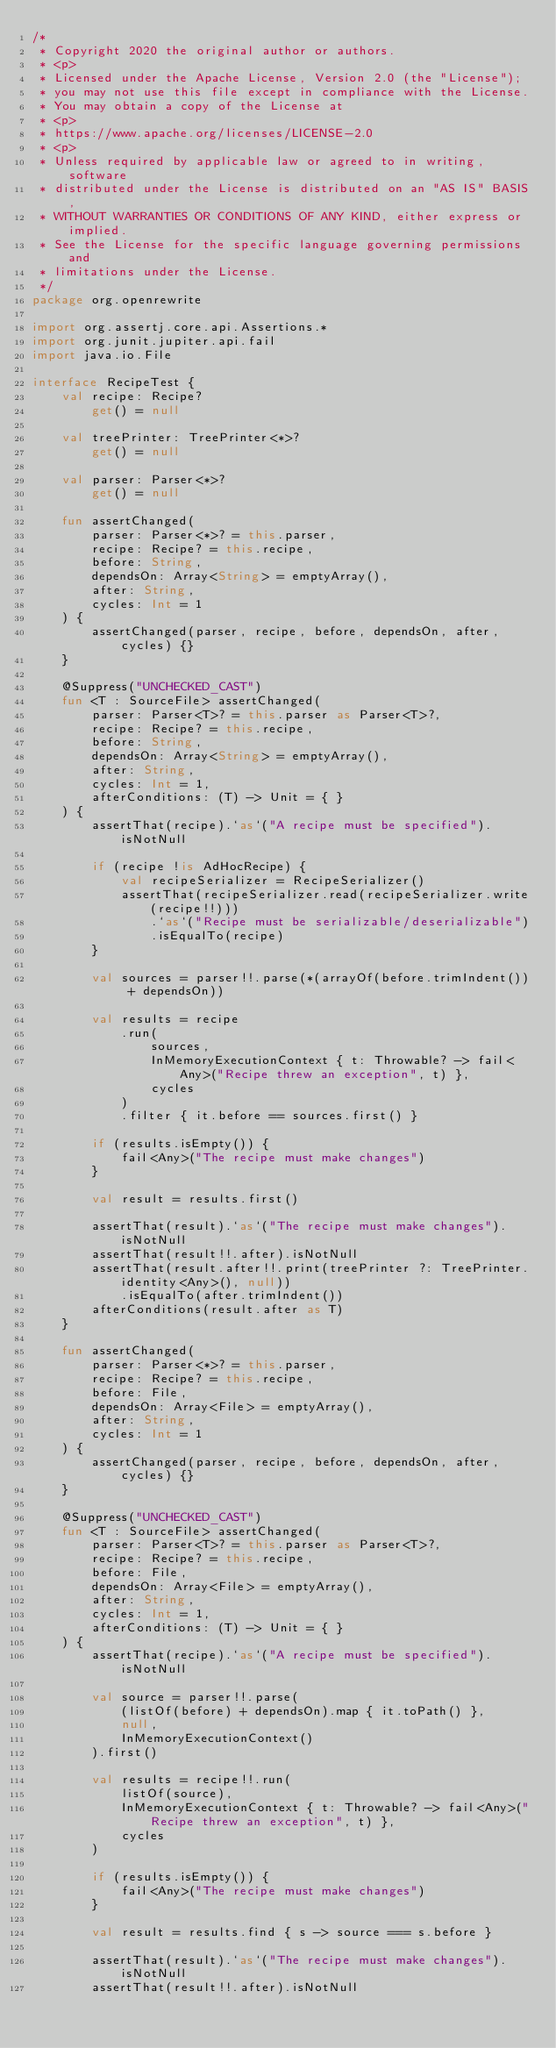<code> <loc_0><loc_0><loc_500><loc_500><_Kotlin_>/*
 * Copyright 2020 the original author or authors.
 * <p>
 * Licensed under the Apache License, Version 2.0 (the "License");
 * you may not use this file except in compliance with the License.
 * You may obtain a copy of the License at
 * <p>
 * https://www.apache.org/licenses/LICENSE-2.0
 * <p>
 * Unless required by applicable law or agreed to in writing, software
 * distributed under the License is distributed on an "AS IS" BASIS,
 * WITHOUT WARRANTIES OR CONDITIONS OF ANY KIND, either express or implied.
 * See the License for the specific language governing permissions and
 * limitations under the License.
 */
package org.openrewrite

import org.assertj.core.api.Assertions.*
import org.junit.jupiter.api.fail
import java.io.File

interface RecipeTest {
    val recipe: Recipe?
        get() = null

    val treePrinter: TreePrinter<*>?
        get() = null

    val parser: Parser<*>?
        get() = null

    fun assertChanged(
        parser: Parser<*>? = this.parser,
        recipe: Recipe? = this.recipe,
        before: String,
        dependsOn: Array<String> = emptyArray(),
        after: String,
        cycles: Int = 1
    ) {
        assertChanged(parser, recipe, before, dependsOn, after, cycles) {}
    }

    @Suppress("UNCHECKED_CAST")
    fun <T : SourceFile> assertChanged(
        parser: Parser<T>? = this.parser as Parser<T>?,
        recipe: Recipe? = this.recipe,
        before: String,
        dependsOn: Array<String> = emptyArray(),
        after: String,
        cycles: Int = 1,
        afterConditions: (T) -> Unit = { }
    ) {
        assertThat(recipe).`as`("A recipe must be specified").isNotNull

        if (recipe !is AdHocRecipe) {
            val recipeSerializer = RecipeSerializer()
            assertThat(recipeSerializer.read(recipeSerializer.write(recipe!!)))
                .`as`("Recipe must be serializable/deserializable")
                .isEqualTo(recipe)
        }

        val sources = parser!!.parse(*(arrayOf(before.trimIndent()) + dependsOn))

        val results = recipe
            .run(
                sources,
                InMemoryExecutionContext { t: Throwable? -> fail<Any>("Recipe threw an exception", t) },
                cycles
            )
            .filter { it.before == sources.first() }

        if (results.isEmpty()) {
            fail<Any>("The recipe must make changes")
        }

        val result = results.first()

        assertThat(result).`as`("The recipe must make changes").isNotNull
        assertThat(result!!.after).isNotNull
        assertThat(result.after!!.print(treePrinter ?: TreePrinter.identity<Any>(), null))
            .isEqualTo(after.trimIndent())
        afterConditions(result.after as T)
    }

    fun assertChanged(
        parser: Parser<*>? = this.parser,
        recipe: Recipe? = this.recipe,
        before: File,
        dependsOn: Array<File> = emptyArray(),
        after: String,
        cycles: Int = 1
    ) {
        assertChanged(parser, recipe, before, dependsOn, after, cycles) {}
    }

    @Suppress("UNCHECKED_CAST")
    fun <T : SourceFile> assertChanged(
        parser: Parser<T>? = this.parser as Parser<T>?,
        recipe: Recipe? = this.recipe,
        before: File,
        dependsOn: Array<File> = emptyArray(),
        after: String,
        cycles: Int = 1,
        afterConditions: (T) -> Unit = { }
    ) {
        assertThat(recipe).`as`("A recipe must be specified").isNotNull

        val source = parser!!.parse(
            (listOf(before) + dependsOn).map { it.toPath() },
            null,
            InMemoryExecutionContext()
        ).first()

        val results = recipe!!.run(
            listOf(source),
            InMemoryExecutionContext { t: Throwable? -> fail<Any>("Recipe threw an exception", t) },
            cycles
        )

        if (results.isEmpty()) {
            fail<Any>("The recipe must make changes")
        }

        val result = results.find { s -> source === s.before }

        assertThat(result).`as`("The recipe must make changes").isNotNull
        assertThat(result!!.after).isNotNull</code> 